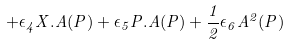Convert formula to latex. <formula><loc_0><loc_0><loc_500><loc_500>+ \epsilon _ { 4 } X . A ( P ) + \epsilon _ { 5 } P . A ( P ) + \frac { 1 } { 2 } \epsilon _ { 6 } A ^ { 2 } ( P )</formula> 